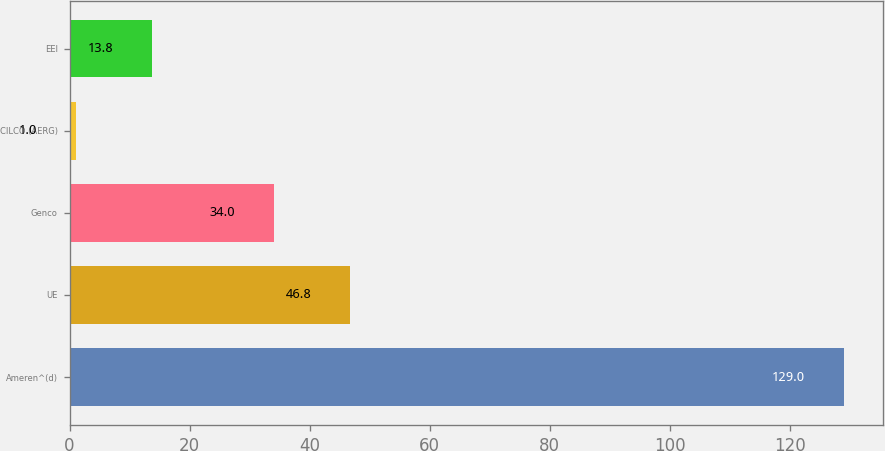Convert chart to OTSL. <chart><loc_0><loc_0><loc_500><loc_500><bar_chart><fcel>Ameren^(d)<fcel>UE<fcel>Genco<fcel>CILCO (AERG)<fcel>EEI<nl><fcel>129<fcel>46.8<fcel>34<fcel>1<fcel>13.8<nl></chart> 